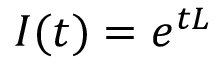Convert formula to latex. <formula><loc_0><loc_0><loc_500><loc_500>I ( t ) = e ^ { t L }</formula> 